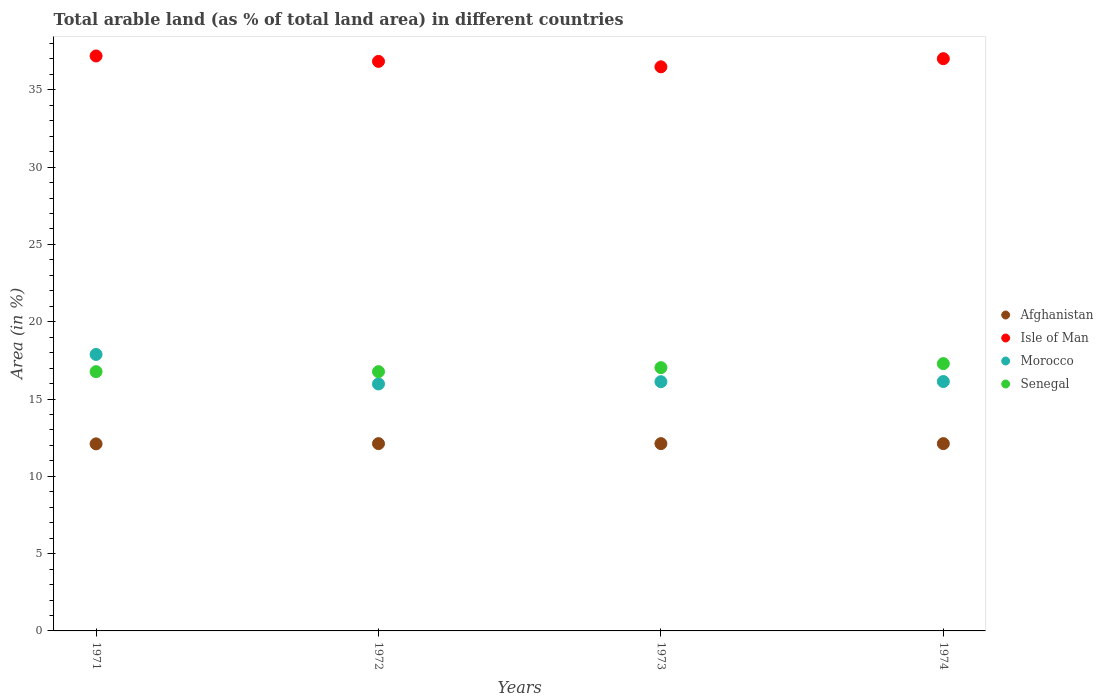Is the number of dotlines equal to the number of legend labels?
Ensure brevity in your answer.  Yes. What is the percentage of arable land in Morocco in 1972?
Provide a short and direct response. 15.98. Across all years, what is the maximum percentage of arable land in Afghanistan?
Offer a very short reply. 12.12. Across all years, what is the minimum percentage of arable land in Afghanistan?
Provide a succinct answer. 12.1. In which year was the percentage of arable land in Afghanistan minimum?
Provide a short and direct response. 1971. What is the total percentage of arable land in Isle of Man in the graph?
Offer a terse response. 147.54. What is the difference between the percentage of arable land in Isle of Man in 1971 and that in 1973?
Provide a succinct answer. 0.7. What is the difference between the percentage of arable land in Isle of Man in 1973 and the percentage of arable land in Afghanistan in 1971?
Your answer should be compact. 24.39. What is the average percentage of arable land in Morocco per year?
Make the answer very short. 16.53. In the year 1973, what is the difference between the percentage of arable land in Afghanistan and percentage of arable land in Isle of Man?
Offer a terse response. -24.38. In how many years, is the percentage of arable land in Isle of Man greater than 35 %?
Keep it short and to the point. 4. What is the ratio of the percentage of arable land in Senegal in 1971 to that in 1974?
Your answer should be compact. 0.97. What is the difference between the highest and the second highest percentage of arable land in Morocco?
Your response must be concise. 1.75. What is the difference between the highest and the lowest percentage of arable land in Isle of Man?
Your answer should be very brief. 0.7. Is it the case that in every year, the sum of the percentage of arable land in Afghanistan and percentage of arable land in Senegal  is greater than the percentage of arable land in Isle of Man?
Provide a succinct answer. No. Is the percentage of arable land in Afghanistan strictly greater than the percentage of arable land in Isle of Man over the years?
Your answer should be compact. No. Is the percentage of arable land in Isle of Man strictly less than the percentage of arable land in Afghanistan over the years?
Your answer should be very brief. No. How many years are there in the graph?
Your answer should be very brief. 4. What is the difference between two consecutive major ticks on the Y-axis?
Ensure brevity in your answer.  5. How are the legend labels stacked?
Keep it short and to the point. Vertical. What is the title of the graph?
Your answer should be compact. Total arable land (as % of total land area) in different countries. Does "Palau" appear as one of the legend labels in the graph?
Make the answer very short. No. What is the label or title of the Y-axis?
Your answer should be compact. Area (in %). What is the Area (in %) of Afghanistan in 1971?
Make the answer very short. 12.1. What is the Area (in %) in Isle of Man in 1971?
Offer a very short reply. 37.19. What is the Area (in %) of Morocco in 1971?
Your response must be concise. 17.89. What is the Area (in %) of Senegal in 1971?
Your answer should be compact. 16.77. What is the Area (in %) of Afghanistan in 1972?
Your response must be concise. 12.12. What is the Area (in %) of Isle of Man in 1972?
Offer a very short reply. 36.84. What is the Area (in %) in Morocco in 1972?
Your response must be concise. 15.98. What is the Area (in %) of Senegal in 1972?
Your answer should be very brief. 16.77. What is the Area (in %) in Afghanistan in 1973?
Your answer should be very brief. 12.12. What is the Area (in %) in Isle of Man in 1973?
Provide a short and direct response. 36.49. What is the Area (in %) of Morocco in 1973?
Give a very brief answer. 16.12. What is the Area (in %) in Senegal in 1973?
Your answer should be compact. 17.03. What is the Area (in %) in Afghanistan in 1974?
Offer a very short reply. 12.12. What is the Area (in %) in Isle of Man in 1974?
Provide a succinct answer. 37.02. What is the Area (in %) of Morocco in 1974?
Your answer should be very brief. 16.13. What is the Area (in %) in Senegal in 1974?
Keep it short and to the point. 17.29. Across all years, what is the maximum Area (in %) of Afghanistan?
Your answer should be compact. 12.12. Across all years, what is the maximum Area (in %) in Isle of Man?
Give a very brief answer. 37.19. Across all years, what is the maximum Area (in %) of Morocco?
Offer a terse response. 17.89. Across all years, what is the maximum Area (in %) of Senegal?
Give a very brief answer. 17.29. Across all years, what is the minimum Area (in %) of Afghanistan?
Offer a very short reply. 12.1. Across all years, what is the minimum Area (in %) in Isle of Man?
Ensure brevity in your answer.  36.49. Across all years, what is the minimum Area (in %) in Morocco?
Your answer should be very brief. 15.98. Across all years, what is the minimum Area (in %) of Senegal?
Offer a very short reply. 16.77. What is the total Area (in %) in Afghanistan in the graph?
Ensure brevity in your answer.  48.45. What is the total Area (in %) of Isle of Man in the graph?
Your answer should be very brief. 147.54. What is the total Area (in %) in Morocco in the graph?
Provide a succinct answer. 66.12. What is the total Area (in %) of Senegal in the graph?
Ensure brevity in your answer.  67.86. What is the difference between the Area (in %) in Afghanistan in 1971 and that in 1972?
Make the answer very short. -0.02. What is the difference between the Area (in %) of Isle of Man in 1971 and that in 1972?
Make the answer very short. 0.35. What is the difference between the Area (in %) of Morocco in 1971 and that in 1972?
Offer a very short reply. 1.91. What is the difference between the Area (in %) in Afghanistan in 1971 and that in 1973?
Make the answer very short. -0.02. What is the difference between the Area (in %) in Isle of Man in 1971 and that in 1973?
Keep it short and to the point. 0.7. What is the difference between the Area (in %) in Morocco in 1971 and that in 1973?
Offer a very short reply. 1.76. What is the difference between the Area (in %) of Senegal in 1971 and that in 1973?
Give a very brief answer. -0.26. What is the difference between the Area (in %) in Afghanistan in 1971 and that in 1974?
Provide a succinct answer. -0.02. What is the difference between the Area (in %) of Isle of Man in 1971 and that in 1974?
Provide a succinct answer. 0.18. What is the difference between the Area (in %) of Morocco in 1971 and that in 1974?
Provide a succinct answer. 1.75. What is the difference between the Area (in %) in Senegal in 1971 and that in 1974?
Provide a succinct answer. -0.52. What is the difference between the Area (in %) in Isle of Man in 1972 and that in 1973?
Give a very brief answer. 0.35. What is the difference between the Area (in %) in Morocco in 1972 and that in 1973?
Give a very brief answer. -0.14. What is the difference between the Area (in %) in Senegal in 1972 and that in 1973?
Your response must be concise. -0.26. What is the difference between the Area (in %) of Afghanistan in 1972 and that in 1974?
Offer a terse response. 0. What is the difference between the Area (in %) in Isle of Man in 1972 and that in 1974?
Provide a short and direct response. -0.18. What is the difference between the Area (in %) of Morocco in 1972 and that in 1974?
Provide a short and direct response. -0.16. What is the difference between the Area (in %) of Senegal in 1972 and that in 1974?
Your answer should be compact. -0.52. What is the difference between the Area (in %) in Afghanistan in 1973 and that in 1974?
Give a very brief answer. 0. What is the difference between the Area (in %) of Isle of Man in 1973 and that in 1974?
Your response must be concise. -0.53. What is the difference between the Area (in %) in Morocco in 1973 and that in 1974?
Keep it short and to the point. -0.01. What is the difference between the Area (in %) in Senegal in 1973 and that in 1974?
Your response must be concise. -0.26. What is the difference between the Area (in %) of Afghanistan in 1971 and the Area (in %) of Isle of Man in 1972?
Ensure brevity in your answer.  -24.74. What is the difference between the Area (in %) of Afghanistan in 1971 and the Area (in %) of Morocco in 1972?
Your response must be concise. -3.88. What is the difference between the Area (in %) of Afghanistan in 1971 and the Area (in %) of Senegal in 1972?
Provide a short and direct response. -4.67. What is the difference between the Area (in %) in Isle of Man in 1971 and the Area (in %) in Morocco in 1972?
Make the answer very short. 21.22. What is the difference between the Area (in %) in Isle of Man in 1971 and the Area (in %) in Senegal in 1972?
Offer a terse response. 20.42. What is the difference between the Area (in %) in Morocco in 1971 and the Area (in %) in Senegal in 1972?
Offer a very short reply. 1.11. What is the difference between the Area (in %) in Afghanistan in 1971 and the Area (in %) in Isle of Man in 1973?
Provide a succinct answer. -24.39. What is the difference between the Area (in %) in Afghanistan in 1971 and the Area (in %) in Morocco in 1973?
Ensure brevity in your answer.  -4.02. What is the difference between the Area (in %) of Afghanistan in 1971 and the Area (in %) of Senegal in 1973?
Keep it short and to the point. -4.93. What is the difference between the Area (in %) of Isle of Man in 1971 and the Area (in %) of Morocco in 1973?
Provide a succinct answer. 21.07. What is the difference between the Area (in %) of Isle of Man in 1971 and the Area (in %) of Senegal in 1973?
Provide a short and direct response. 20.16. What is the difference between the Area (in %) in Morocco in 1971 and the Area (in %) in Senegal in 1973?
Your answer should be very brief. 0.85. What is the difference between the Area (in %) in Afghanistan in 1971 and the Area (in %) in Isle of Man in 1974?
Offer a terse response. -24.92. What is the difference between the Area (in %) in Afghanistan in 1971 and the Area (in %) in Morocco in 1974?
Your response must be concise. -4.03. What is the difference between the Area (in %) in Afghanistan in 1971 and the Area (in %) in Senegal in 1974?
Make the answer very short. -5.19. What is the difference between the Area (in %) of Isle of Man in 1971 and the Area (in %) of Morocco in 1974?
Provide a short and direct response. 21.06. What is the difference between the Area (in %) of Isle of Man in 1971 and the Area (in %) of Senegal in 1974?
Your answer should be very brief. 19.9. What is the difference between the Area (in %) in Morocco in 1971 and the Area (in %) in Senegal in 1974?
Your answer should be very brief. 0.59. What is the difference between the Area (in %) in Afghanistan in 1972 and the Area (in %) in Isle of Man in 1973?
Offer a terse response. -24.38. What is the difference between the Area (in %) in Afghanistan in 1972 and the Area (in %) in Morocco in 1973?
Your response must be concise. -4.01. What is the difference between the Area (in %) of Afghanistan in 1972 and the Area (in %) of Senegal in 1973?
Provide a succinct answer. -4.92. What is the difference between the Area (in %) in Isle of Man in 1972 and the Area (in %) in Morocco in 1973?
Your response must be concise. 20.72. What is the difference between the Area (in %) in Isle of Man in 1972 and the Area (in %) in Senegal in 1973?
Ensure brevity in your answer.  19.81. What is the difference between the Area (in %) of Morocco in 1972 and the Area (in %) of Senegal in 1973?
Ensure brevity in your answer.  -1.05. What is the difference between the Area (in %) in Afghanistan in 1972 and the Area (in %) in Isle of Man in 1974?
Give a very brief answer. -24.9. What is the difference between the Area (in %) of Afghanistan in 1972 and the Area (in %) of Morocco in 1974?
Your answer should be compact. -4.02. What is the difference between the Area (in %) in Afghanistan in 1972 and the Area (in %) in Senegal in 1974?
Your response must be concise. -5.17. What is the difference between the Area (in %) in Isle of Man in 1972 and the Area (in %) in Morocco in 1974?
Provide a succinct answer. 20.71. What is the difference between the Area (in %) in Isle of Man in 1972 and the Area (in %) in Senegal in 1974?
Give a very brief answer. 19.55. What is the difference between the Area (in %) in Morocco in 1972 and the Area (in %) in Senegal in 1974?
Give a very brief answer. -1.31. What is the difference between the Area (in %) in Afghanistan in 1973 and the Area (in %) in Isle of Man in 1974?
Your response must be concise. -24.9. What is the difference between the Area (in %) of Afghanistan in 1973 and the Area (in %) of Morocco in 1974?
Your response must be concise. -4.02. What is the difference between the Area (in %) in Afghanistan in 1973 and the Area (in %) in Senegal in 1974?
Keep it short and to the point. -5.17. What is the difference between the Area (in %) of Isle of Man in 1973 and the Area (in %) of Morocco in 1974?
Provide a succinct answer. 20.36. What is the difference between the Area (in %) of Isle of Man in 1973 and the Area (in %) of Senegal in 1974?
Offer a terse response. 19.2. What is the difference between the Area (in %) of Morocco in 1973 and the Area (in %) of Senegal in 1974?
Provide a succinct answer. -1.17. What is the average Area (in %) of Afghanistan per year?
Provide a succinct answer. 12.11. What is the average Area (in %) of Isle of Man per year?
Make the answer very short. 36.89. What is the average Area (in %) in Morocco per year?
Your response must be concise. 16.53. What is the average Area (in %) in Senegal per year?
Offer a terse response. 16.97. In the year 1971, what is the difference between the Area (in %) in Afghanistan and Area (in %) in Isle of Man?
Your answer should be compact. -25.09. In the year 1971, what is the difference between the Area (in %) in Afghanistan and Area (in %) in Morocco?
Your answer should be very brief. -5.78. In the year 1971, what is the difference between the Area (in %) of Afghanistan and Area (in %) of Senegal?
Offer a very short reply. -4.67. In the year 1971, what is the difference between the Area (in %) of Isle of Man and Area (in %) of Morocco?
Keep it short and to the point. 19.31. In the year 1971, what is the difference between the Area (in %) of Isle of Man and Area (in %) of Senegal?
Ensure brevity in your answer.  20.42. In the year 1971, what is the difference between the Area (in %) of Morocco and Area (in %) of Senegal?
Provide a short and direct response. 1.11. In the year 1972, what is the difference between the Area (in %) of Afghanistan and Area (in %) of Isle of Man?
Give a very brief answer. -24.73. In the year 1972, what is the difference between the Area (in %) of Afghanistan and Area (in %) of Morocco?
Give a very brief answer. -3.86. In the year 1972, what is the difference between the Area (in %) of Afghanistan and Area (in %) of Senegal?
Offer a very short reply. -4.66. In the year 1972, what is the difference between the Area (in %) in Isle of Man and Area (in %) in Morocco?
Offer a terse response. 20.87. In the year 1972, what is the difference between the Area (in %) in Isle of Man and Area (in %) in Senegal?
Keep it short and to the point. 20.07. In the year 1972, what is the difference between the Area (in %) of Morocco and Area (in %) of Senegal?
Give a very brief answer. -0.79. In the year 1973, what is the difference between the Area (in %) in Afghanistan and Area (in %) in Isle of Man?
Make the answer very short. -24.38. In the year 1973, what is the difference between the Area (in %) in Afghanistan and Area (in %) in Morocco?
Keep it short and to the point. -4.01. In the year 1973, what is the difference between the Area (in %) in Afghanistan and Area (in %) in Senegal?
Offer a very short reply. -4.92. In the year 1973, what is the difference between the Area (in %) in Isle of Man and Area (in %) in Morocco?
Ensure brevity in your answer.  20.37. In the year 1973, what is the difference between the Area (in %) in Isle of Man and Area (in %) in Senegal?
Your answer should be very brief. 19.46. In the year 1973, what is the difference between the Area (in %) in Morocco and Area (in %) in Senegal?
Offer a terse response. -0.91. In the year 1974, what is the difference between the Area (in %) of Afghanistan and Area (in %) of Isle of Man?
Provide a short and direct response. -24.9. In the year 1974, what is the difference between the Area (in %) of Afghanistan and Area (in %) of Morocco?
Offer a very short reply. -4.02. In the year 1974, what is the difference between the Area (in %) of Afghanistan and Area (in %) of Senegal?
Keep it short and to the point. -5.17. In the year 1974, what is the difference between the Area (in %) in Isle of Man and Area (in %) in Morocco?
Offer a very short reply. 20.88. In the year 1974, what is the difference between the Area (in %) of Isle of Man and Area (in %) of Senegal?
Provide a short and direct response. 19.73. In the year 1974, what is the difference between the Area (in %) of Morocco and Area (in %) of Senegal?
Offer a terse response. -1.16. What is the ratio of the Area (in %) of Afghanistan in 1971 to that in 1972?
Provide a short and direct response. 1. What is the ratio of the Area (in %) in Isle of Man in 1971 to that in 1972?
Give a very brief answer. 1.01. What is the ratio of the Area (in %) of Morocco in 1971 to that in 1972?
Provide a succinct answer. 1.12. What is the ratio of the Area (in %) of Senegal in 1971 to that in 1972?
Offer a very short reply. 1. What is the ratio of the Area (in %) of Afghanistan in 1971 to that in 1973?
Give a very brief answer. 1. What is the ratio of the Area (in %) in Isle of Man in 1971 to that in 1973?
Ensure brevity in your answer.  1.02. What is the ratio of the Area (in %) of Morocco in 1971 to that in 1973?
Provide a short and direct response. 1.11. What is the ratio of the Area (in %) of Afghanistan in 1971 to that in 1974?
Make the answer very short. 1. What is the ratio of the Area (in %) in Isle of Man in 1971 to that in 1974?
Your response must be concise. 1. What is the ratio of the Area (in %) in Morocco in 1971 to that in 1974?
Provide a short and direct response. 1.11. What is the ratio of the Area (in %) in Isle of Man in 1972 to that in 1973?
Offer a very short reply. 1.01. What is the ratio of the Area (in %) in Isle of Man in 1972 to that in 1974?
Give a very brief answer. 1. What is the ratio of the Area (in %) of Morocco in 1972 to that in 1974?
Your answer should be compact. 0.99. What is the ratio of the Area (in %) of Senegal in 1972 to that in 1974?
Offer a terse response. 0.97. What is the ratio of the Area (in %) of Afghanistan in 1973 to that in 1974?
Your answer should be very brief. 1. What is the ratio of the Area (in %) of Isle of Man in 1973 to that in 1974?
Offer a very short reply. 0.99. What is the ratio of the Area (in %) of Morocco in 1973 to that in 1974?
Provide a succinct answer. 1. What is the difference between the highest and the second highest Area (in %) in Isle of Man?
Offer a terse response. 0.18. What is the difference between the highest and the second highest Area (in %) in Morocco?
Keep it short and to the point. 1.75. What is the difference between the highest and the second highest Area (in %) of Senegal?
Your answer should be very brief. 0.26. What is the difference between the highest and the lowest Area (in %) of Afghanistan?
Offer a terse response. 0.02. What is the difference between the highest and the lowest Area (in %) in Isle of Man?
Give a very brief answer. 0.7. What is the difference between the highest and the lowest Area (in %) in Morocco?
Your answer should be compact. 1.91. What is the difference between the highest and the lowest Area (in %) of Senegal?
Give a very brief answer. 0.52. 